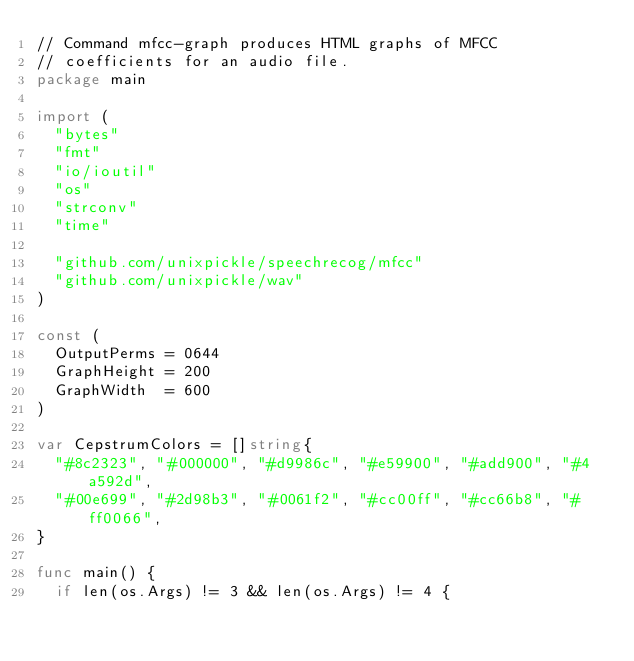Convert code to text. <code><loc_0><loc_0><loc_500><loc_500><_Go_>// Command mfcc-graph produces HTML graphs of MFCC
// coefficients for an audio file.
package main

import (
	"bytes"
	"fmt"
	"io/ioutil"
	"os"
	"strconv"
	"time"

	"github.com/unixpickle/speechrecog/mfcc"
	"github.com/unixpickle/wav"
)

const (
	OutputPerms = 0644
	GraphHeight = 200
	GraphWidth  = 600
)

var CepstrumColors = []string{
	"#8c2323", "#000000", "#d9986c", "#e59900", "#add900", "#4a592d",
	"#00e699", "#2d98b3", "#0061f2", "#cc00ff", "#cc66b8", "#ff0066",
}

func main() {
	if len(os.Args) != 3 && len(os.Args) != 4 {</code> 